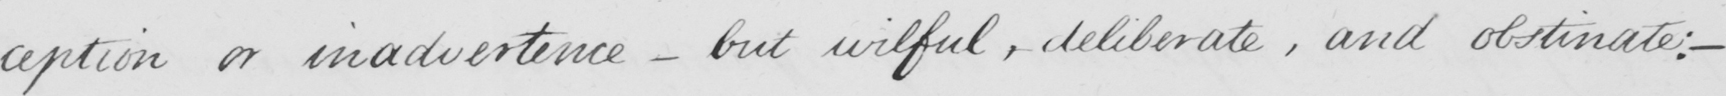Please provide the text content of this handwritten line. -ception or inadvertence  _  but , wilful , deliberate , and obstinate :   _ 